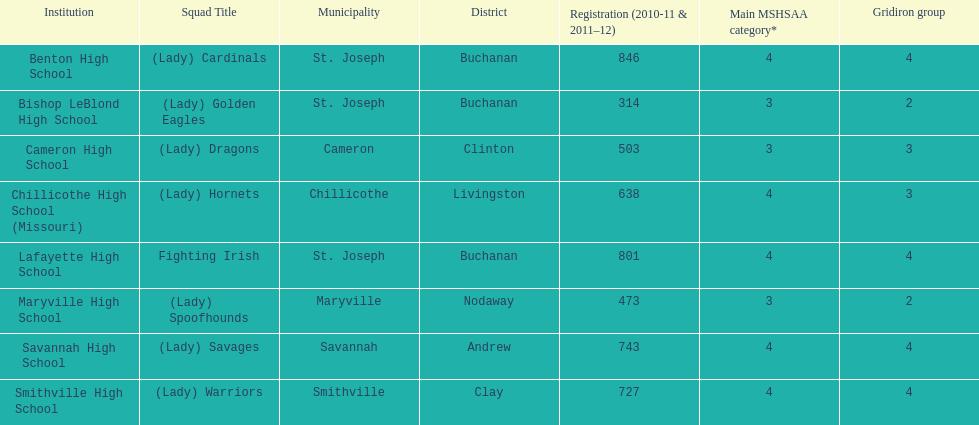Which school has the largest enrollment? Benton High School. 